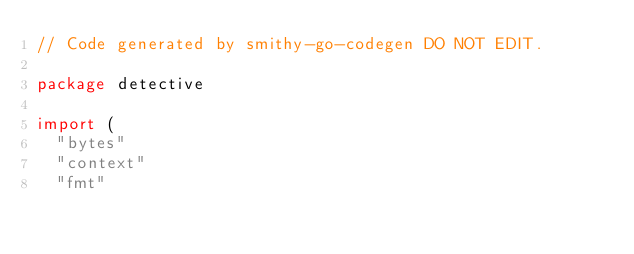Convert code to text. <code><loc_0><loc_0><loc_500><loc_500><_Go_>// Code generated by smithy-go-codegen DO NOT EDIT.

package detective

import (
	"bytes"
	"context"
	"fmt"</code> 